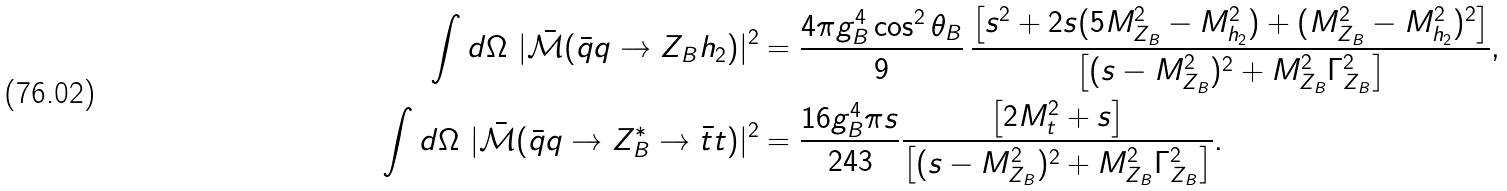Convert formula to latex. <formula><loc_0><loc_0><loc_500><loc_500>\int d \Omega \ | \bar { \mathcal { M } } ( \bar { q } q \to Z _ { B } h _ { 2 } ) | ^ { 2 } & = \frac { 4 \pi g _ { B } ^ { 4 } \cos ^ { 2 } \theta _ { B } } { 9 } \, \frac { \left [ s ^ { 2 } + 2 s ( 5 M _ { Z _ { B } } ^ { 2 } - M _ { h _ { 2 } } ^ { 2 } ) + ( M _ { Z _ { B } } ^ { 2 } - M _ { h _ { 2 } } ^ { 2 } ) ^ { 2 } \right ] } { \left [ ( s - M _ { Z _ { B } } ^ { 2 } ) ^ { 2 } + M _ { Z _ { B } } ^ { 2 } \Gamma _ { Z _ { B } } ^ { 2 } \right ] } , \\ \int d \Omega \ | \bar { \mathcal { M } } ( \bar { q } q \to Z _ { B } ^ { * } \to \bar { t } t ) | ^ { 2 } & = \frac { 1 6 g _ { B } ^ { 4 } \pi s } { 2 4 3 } \frac { \left [ 2 M _ { t } ^ { 2 } + s \right ] } { \left [ ( s - M _ { Z _ { B } } ^ { 2 } ) ^ { 2 } + M _ { Z _ { B } } ^ { 2 } \Gamma _ { Z _ { B } } ^ { 2 } \right ] } .</formula> 